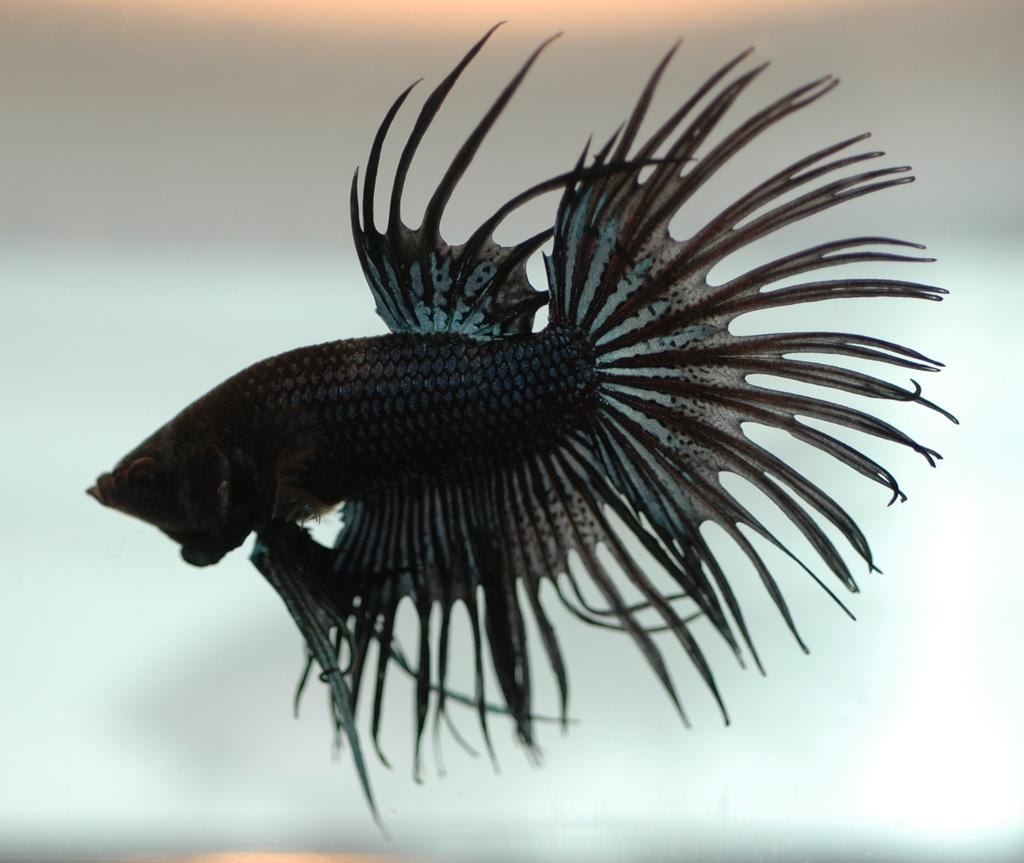What is in the water in the image? There is a fish in the water in the image. Can you describe the background of the image? The background of the image is blurred. What type of yarn is the zebra using to create an amusement park in the image? There is no yarn, zebra, or amusement park present in the image. 